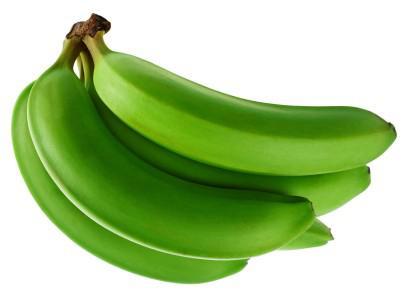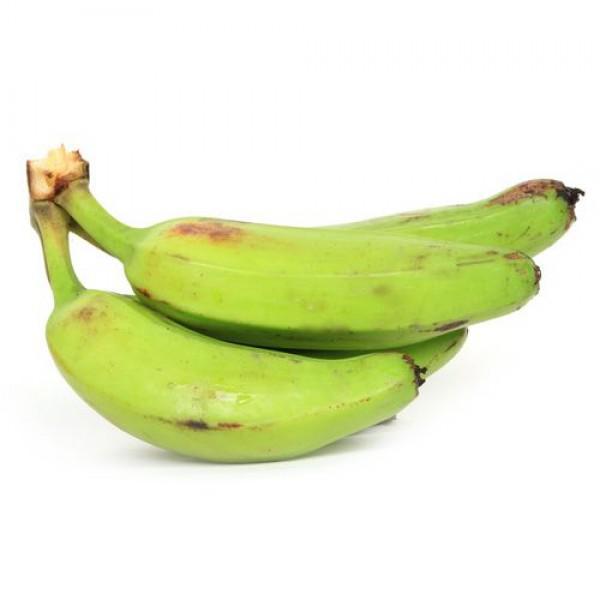The first image is the image on the left, the second image is the image on the right. Analyze the images presented: Is the assertion "One of the images is exactly three green bananas, and this particular bunch is not connected." valid? Answer yes or no. No. 